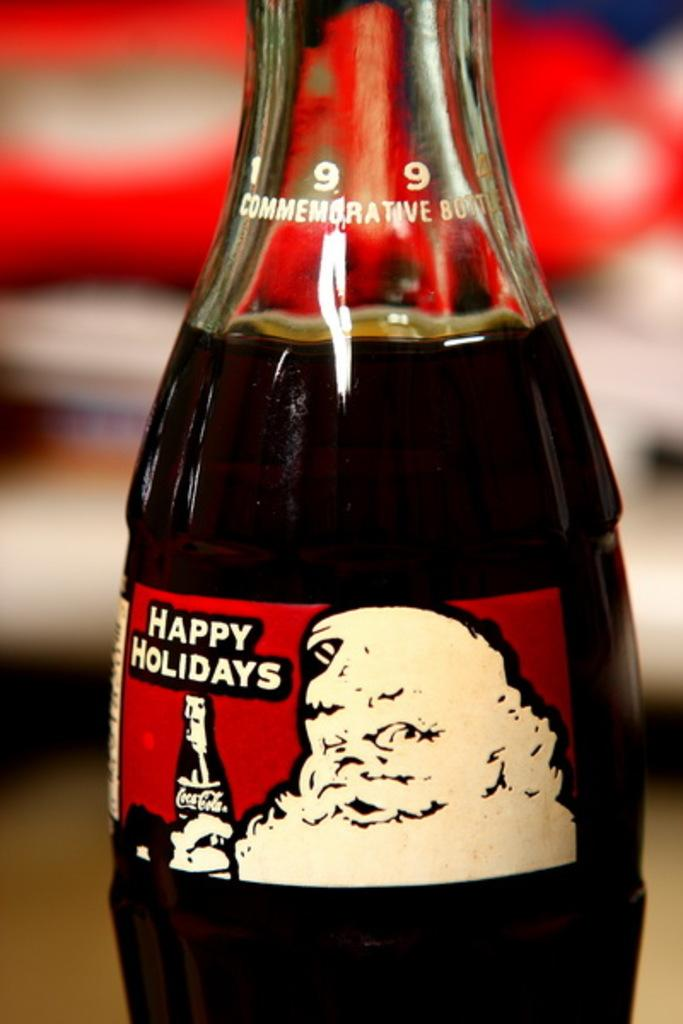What is the main object in the image? There is a coke bottle in the image. What can be seen on the coke bottle? The coke bottle has a label on it. What type of grape is being used as a pillow in the image? There is no grape or bed present in the image, so it cannot be determined if a grape is being used as a pillow. 